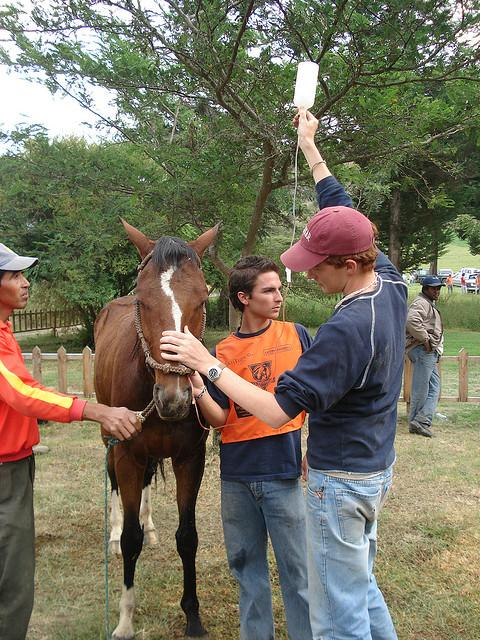What item is held up by the man here? Please explain your reasoning. iv bag. Men are standing around with their hands on a horse. one of the men is holding a bottle with a line connected to it up near the horse. 